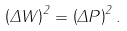Convert formula to latex. <formula><loc_0><loc_0><loc_500><loc_500>\left ( \Delta W \right ) ^ { 2 } = \left ( \Delta P \right ) ^ { 2 } .</formula> 